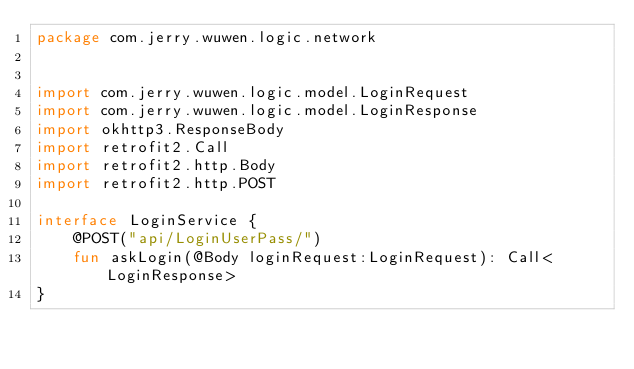Convert code to text. <code><loc_0><loc_0><loc_500><loc_500><_Kotlin_>package com.jerry.wuwen.logic.network


import com.jerry.wuwen.logic.model.LoginRequest
import com.jerry.wuwen.logic.model.LoginResponse
import okhttp3.ResponseBody
import retrofit2.Call
import retrofit2.http.Body
import retrofit2.http.POST

interface LoginService {
    @POST("api/LoginUserPass/")
    fun askLogin(@Body loginRequest:LoginRequest): Call<LoginResponse>
}</code> 